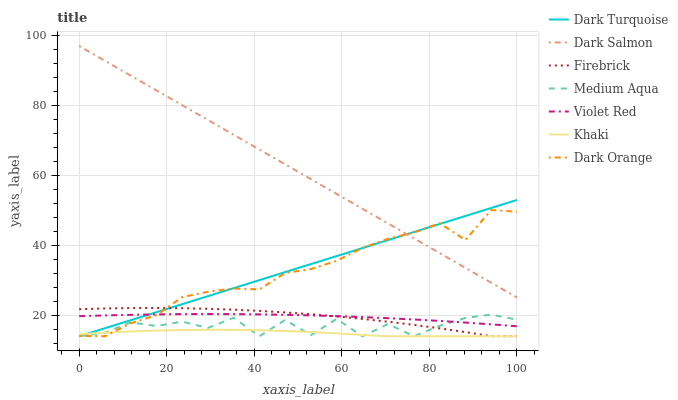Does Khaki have the minimum area under the curve?
Answer yes or no. Yes. Does Dark Salmon have the maximum area under the curve?
Answer yes or no. Yes. Does Violet Red have the minimum area under the curve?
Answer yes or no. No. Does Violet Red have the maximum area under the curve?
Answer yes or no. No. Is Dark Turquoise the smoothest?
Answer yes or no. Yes. Is Medium Aqua the roughest?
Answer yes or no. Yes. Is Violet Red the smoothest?
Answer yes or no. No. Is Violet Red the roughest?
Answer yes or no. No. Does Violet Red have the lowest value?
Answer yes or no. No. Does Dark Salmon have the highest value?
Answer yes or no. Yes. Does Violet Red have the highest value?
Answer yes or no. No. Is Medium Aqua less than Dark Salmon?
Answer yes or no. Yes. Is Dark Salmon greater than Medium Aqua?
Answer yes or no. Yes. Does Dark Orange intersect Firebrick?
Answer yes or no. Yes. Is Dark Orange less than Firebrick?
Answer yes or no. No. Is Dark Orange greater than Firebrick?
Answer yes or no. No. Does Medium Aqua intersect Dark Salmon?
Answer yes or no. No. 